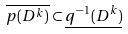Convert formula to latex. <formula><loc_0><loc_0><loc_500><loc_500>\overline { p ( D ^ { k } ) } \subset \underline { q ^ { - 1 } ( D ^ { k } ) }</formula> 